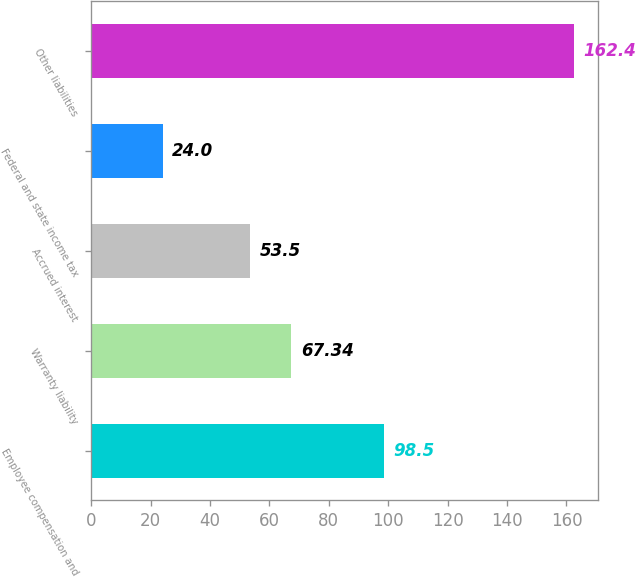Convert chart to OTSL. <chart><loc_0><loc_0><loc_500><loc_500><bar_chart><fcel>Employee compensation and<fcel>Warranty liability<fcel>Accrued interest<fcel>Federal and state income tax<fcel>Other liabilities<nl><fcel>98.5<fcel>67.34<fcel>53.5<fcel>24<fcel>162.4<nl></chart> 